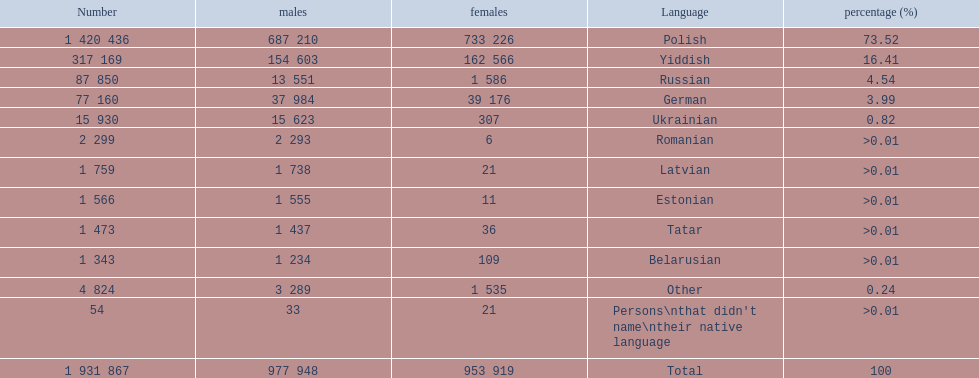What named native languages spoken in the warsaw governorate have more males then females? Russian, Ukrainian, Romanian, Latvian, Estonian, Tatar, Belarusian. Which of those have less then 500 males listed? Romanian, Latvian, Estonian, Tatar, Belarusian. Of the remaining languages which of them have less then 20 females? Romanian, Estonian. Which of these has the highest total number listed? Romanian. 